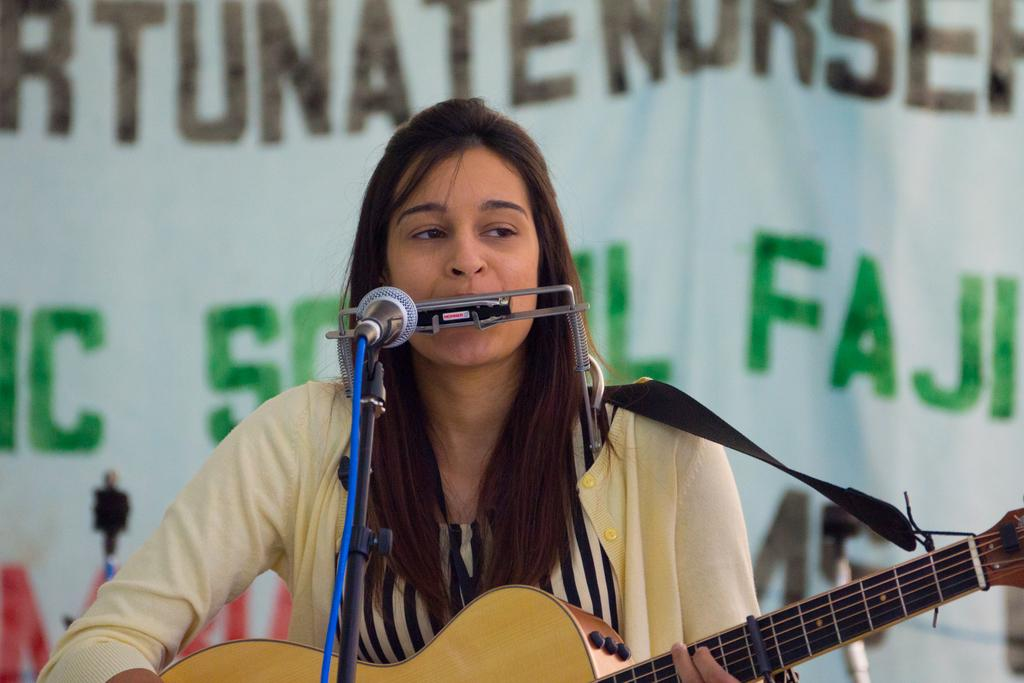What is the woman in the image doing? The woman is singing and playing a guitar in the image. What instrument is the woman playing? The woman is playing a guitar in the image. What activity is the woman engaged in while playing the guitar? The woman is singing while playing the guitar. What type of riddle is the woman solving in the image? There is no riddle present in the image; the woman is singing and playing a guitar. What arithmetic problem is the woman solving in the image? There is no arithmetic problem present in the image; the woman is singing and playing a guitar. 